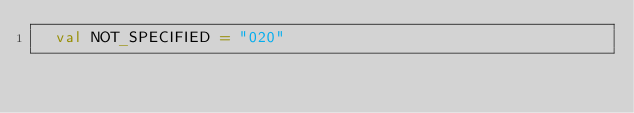Convert code to text. <code><loc_0><loc_0><loc_500><loc_500><_Scala_>  val NOT_SPECIFIED = "020"</code> 